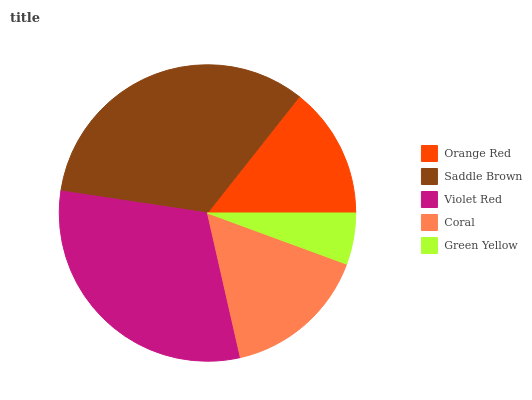Is Green Yellow the minimum?
Answer yes or no. Yes. Is Saddle Brown the maximum?
Answer yes or no. Yes. Is Violet Red the minimum?
Answer yes or no. No. Is Violet Red the maximum?
Answer yes or no. No. Is Saddle Brown greater than Violet Red?
Answer yes or no. Yes. Is Violet Red less than Saddle Brown?
Answer yes or no. Yes. Is Violet Red greater than Saddle Brown?
Answer yes or no. No. Is Saddle Brown less than Violet Red?
Answer yes or no. No. Is Coral the high median?
Answer yes or no. Yes. Is Coral the low median?
Answer yes or no. Yes. Is Green Yellow the high median?
Answer yes or no. No. Is Orange Red the low median?
Answer yes or no. No. 